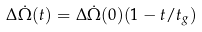<formula> <loc_0><loc_0><loc_500><loc_500>\Delta \dot { \Omega } ( t ) = \Delta \dot { \Omega } ( 0 ) ( 1 - t / t _ { g } )</formula> 